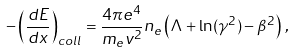<formula> <loc_0><loc_0><loc_500><loc_500>- \left ( \frac { d E } { d x } \right ) _ { c o l l } = \frac { 4 \pi e ^ { 4 } } { m _ { e } v ^ { 2 } } n _ { e } \left ( \Lambda + \ln ( \gamma ^ { 2 } ) - \beta ^ { 2 } \right ) \, ,</formula> 